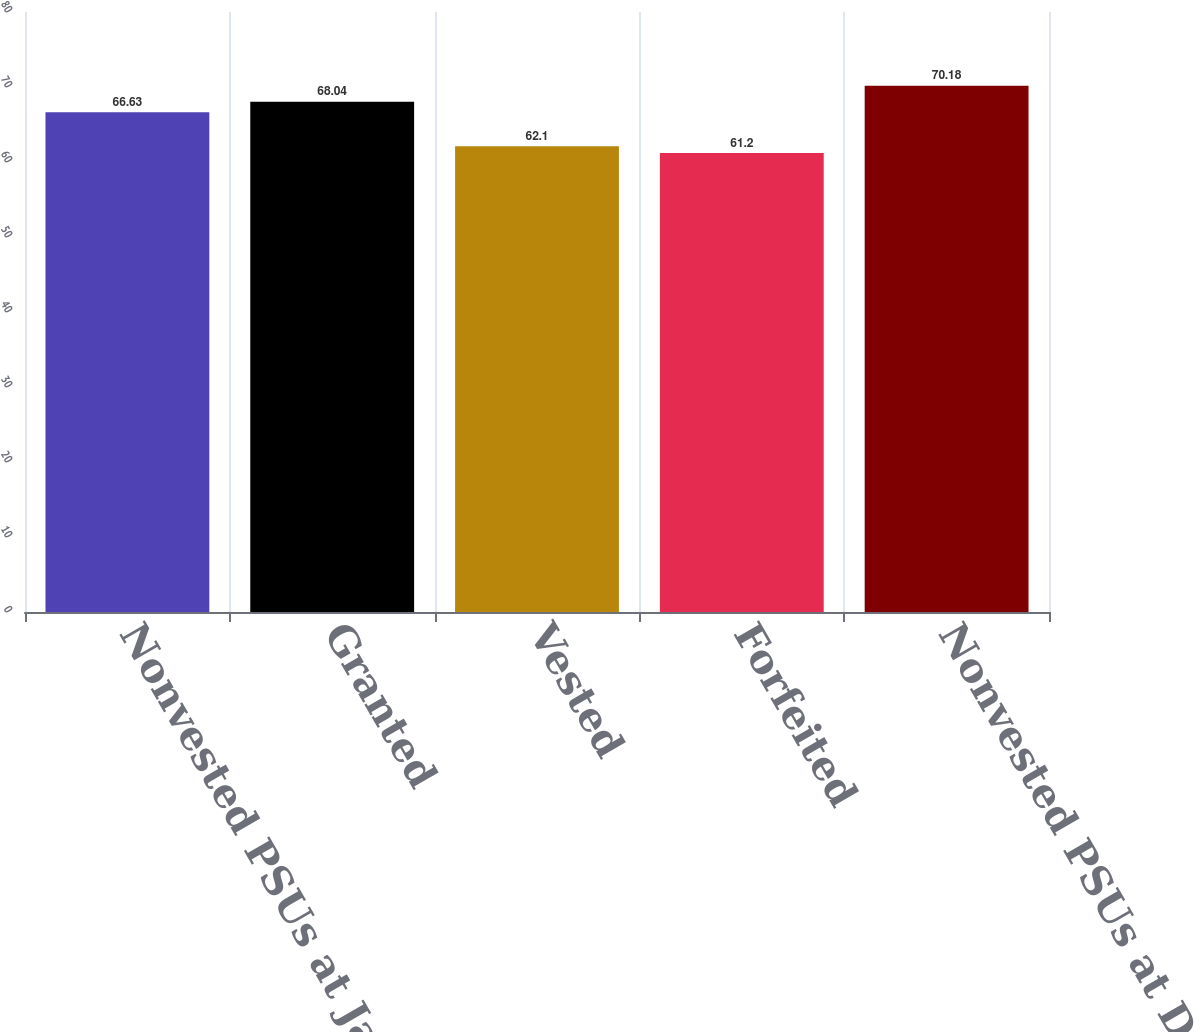Convert chart. <chart><loc_0><loc_0><loc_500><loc_500><bar_chart><fcel>Nonvested PSUs at January 1<fcel>Granted<fcel>Vested<fcel>Forfeited<fcel>Nonvested PSUs at December 31<nl><fcel>66.63<fcel>68.04<fcel>62.1<fcel>61.2<fcel>70.18<nl></chart> 